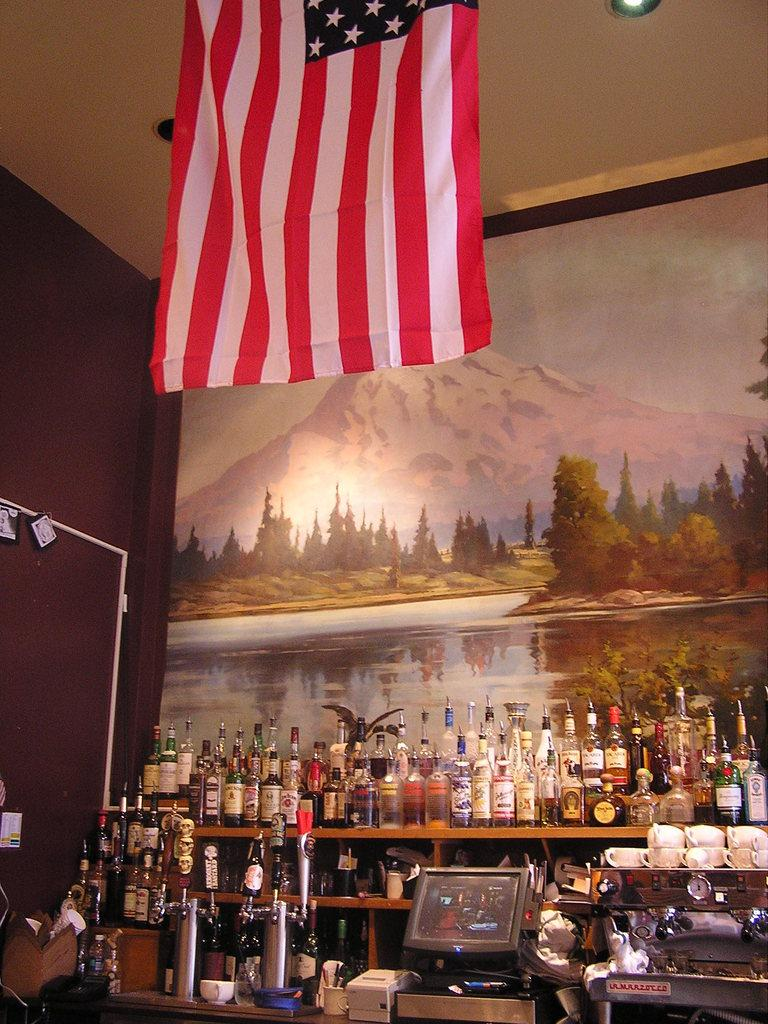What objects are on the shelf in the image? There are bottles on a shelf in the image. Where is the shelf located in the image? The shelf is at the bottom of the image. What can be seen on the wall in the background of the image? There is a painting on a wall in the background of the image. What is at the top of the image? There is a flag at the top of the image. What is the number of curves in the flag at the top of the image? There is no information about the number of curves in the flag, as the flag's design is not described in the facts. 